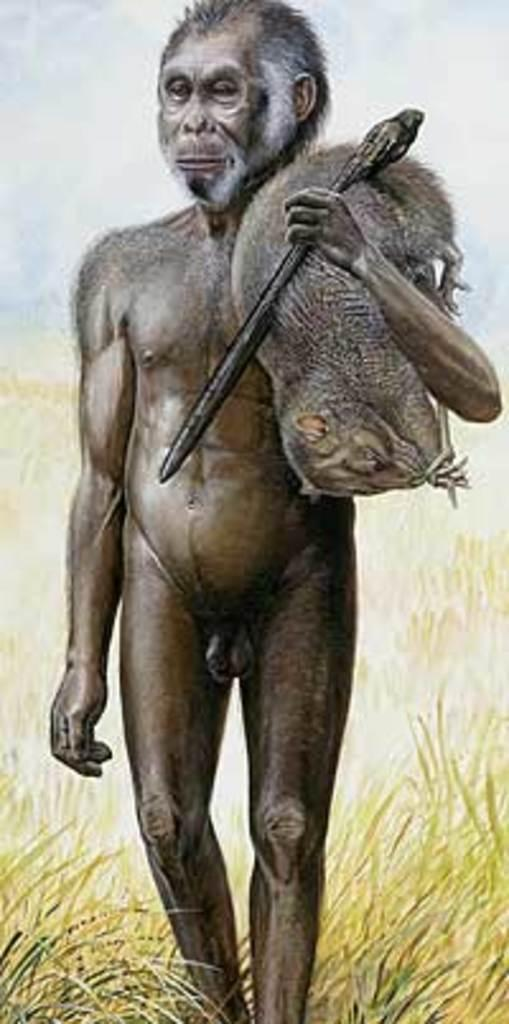What is the main subject of the image? There is a statue of an early man in the image. What is the early man holding in the statue? The early man is holding an animal and a stick. What type of terrain is depicted at the bottom of the image? There is grass at the bottom of the image. What can be seen in the background of the image? The sky is visible in the background of the image. What note is the early man playing on the chessboard in the image? There is no chessboard or note present in the image; it features a statue of an early man holding an animal and a stick. 